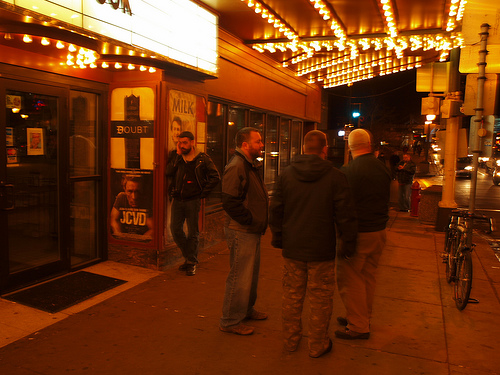<image>
Can you confirm if the man is to the left of the man? No. The man is not to the left of the man. From this viewpoint, they have a different horizontal relationship. 